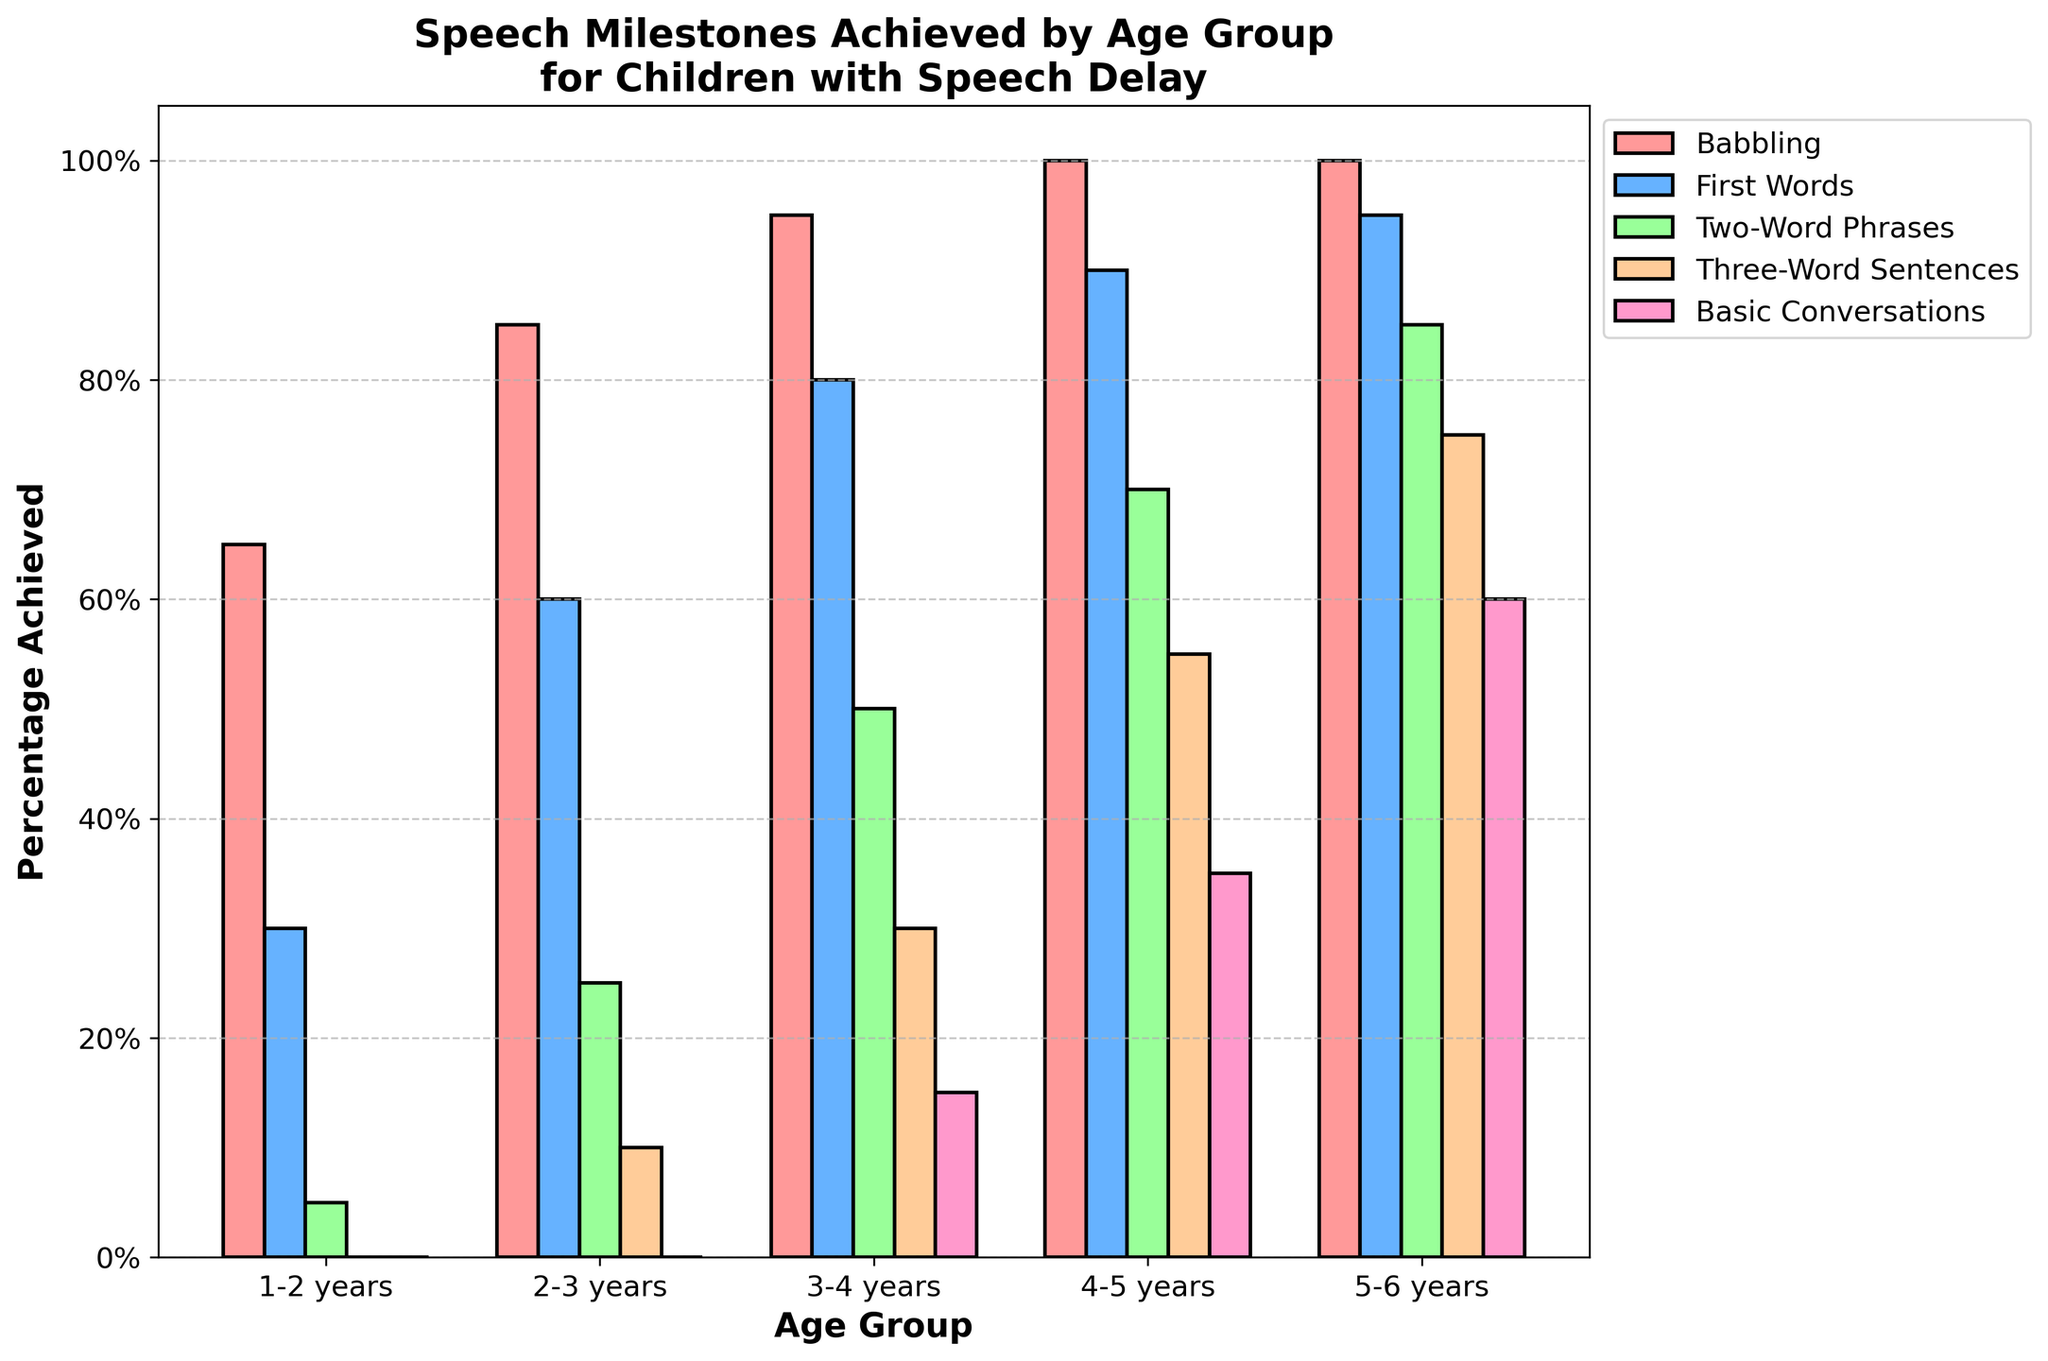What percentage of children aged 3-4 years can engage in basic conversations? Look for the "Basic Conversations" bar for the age group 3-4 years. The height of the bar indicates 15%.
Answer: 15% Which milestone shows the largest percentage increase between age groups 1-2 and 2-3 years? Calculate the percentage increases for each milestone between these age groups. "Babbling" increases from 65% to 85% (a 20% increase), "First Words" from 30% to 60% (a 30% increase), "Two-Word Phrases" from 5% to 25% (a 20% increase), and "Three-Word Sentences" from 0% to 10% (a 10% increase). "First Words" has the largest increase.
Answer: First Words Compare the percentage of children who can form two-word phrases at ages 2-3 and 4-5 years. Which age group has a higher percentage? Referring to the chart, "Two-Word Phrases" for the age group 2-3 years is 25%, and for the age group 4-5 years, it is 70%.
Answer: Age group 4-5 years How many age groups show 100% achievement in babbling? Identify the bars for "Babbling" milestone and count the number of age groups that reach 100%. The age groups 4-5 and 5-6 both show 100%.
Answer: 2 At what age does the percentage of children who can form three-word sentences first reach 50%? Look at the "Three-Word Sentences" milestone and find the age group where the bar first reaches or exceeds 50%. It is at age group 3-4 years.
Answer: 3-4 years What is the average achievement percentage for 'First Words' across all age groups? Sum the percentages for 'First Words' (30% + 60% + 80% + 90% + 95%) and then divide by the number of age groups, which is 5. So, (30 + 60 + 80 + 90 + 95) / 5 = 71%.
Answer: 71% How much higher is the percentage of children who can engage in basic conversations at ages 5-6 compared to 4-5 years? Subtract the percentage for basic conversations at 4-5 years (35%) from that at 5-6 years (60%). The difference is 60% - 35%.
Answer: 25% Identify which milestone is least achieved by children aged 2-3 years. Compare the heights of the bars for age group 2-3 years. "Three-Word Sentences" is the lowest at 10%.
Answer: Three-Word Sentences Between ages 3-4 and 5-6, which milestone shows the greatest increase in achievement? Calculate the difference for each milestone between these age groups. "Babbling" (5% increase), "First Words" (15% increase), "Two-Word Phrases" (35% increase), "Three-Word Sentences" (45% increase), and "Basic Conversations" (45% increase). Both "Three-Word Sentences" and "Basic Conversations" show the greatest increase.
Answer: Three-Word Sentences and Basic Conversations 